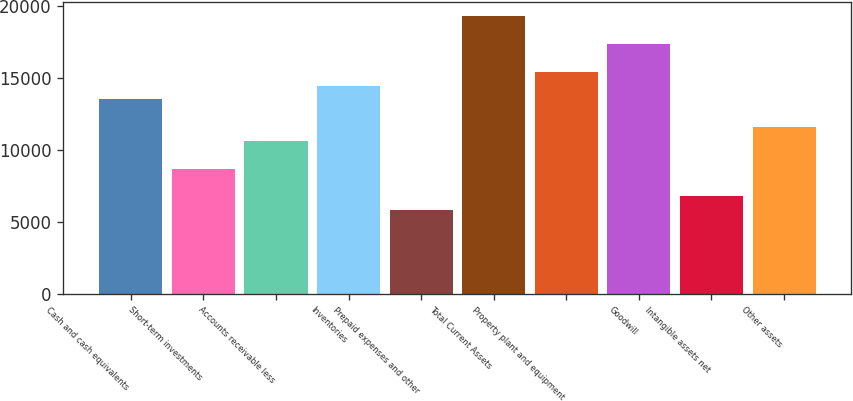<chart> <loc_0><loc_0><loc_500><loc_500><bar_chart><fcel>Cash and cash equivalents<fcel>Short-term investments<fcel>Accounts receivable less<fcel>Inventories<fcel>Prepaid expenses and other<fcel>Total Current Assets<fcel>Property plant and equipment<fcel>Goodwill<fcel>Intangible assets net<fcel>Other assets<nl><fcel>13520.5<fcel>8692.38<fcel>10623.6<fcel>14486.1<fcel>5795.52<fcel>19314.2<fcel>15451.7<fcel>17383<fcel>6761.14<fcel>11589.2<nl></chart> 